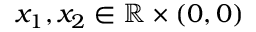Convert formula to latex. <formula><loc_0><loc_0><loc_500><loc_500>x _ { 1 } , x _ { 2 } \in \mathbb { R } \times ( 0 , 0 )</formula> 